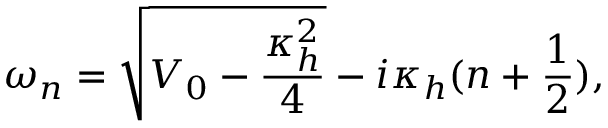Convert formula to latex. <formula><loc_0><loc_0><loc_500><loc_500>\omega _ { n } = \sqrt { V _ { 0 } - \frac { \kappa _ { h } ^ { 2 } } { 4 } } - i \kappa _ { h } ( n + \frac { 1 } { 2 } ) ,</formula> 